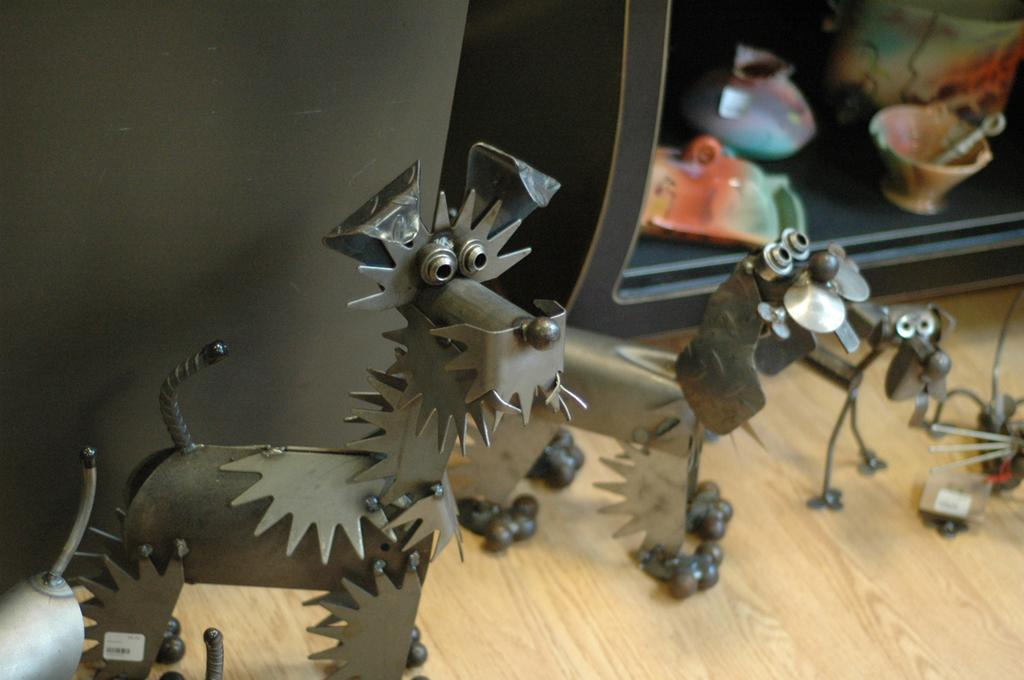What can be seen in the image related to equipment? There is equipment in the image. Can you describe any specific structures or features in the image? There is a stand in the image. What is placed on the stand? There are things placed on the stand. How does the equipment help in learning in the image? The image does not show any learning or educational context, so it is not possible to determine how the equipment might be related to learning. Can you hear a whistle in the image? There is no mention of a whistle in the image, so it cannot be heard or seen. 